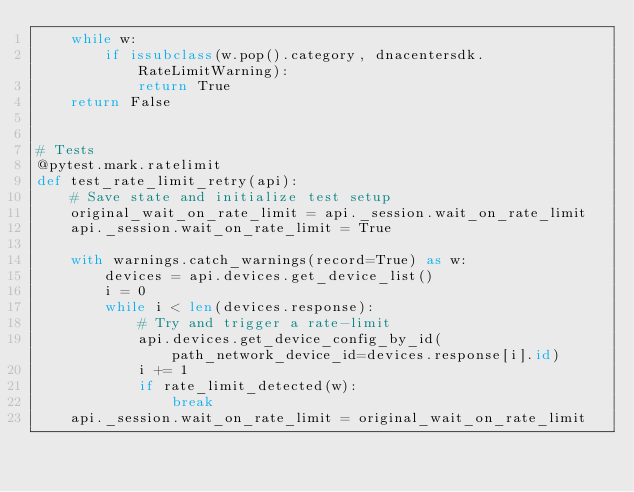<code> <loc_0><loc_0><loc_500><loc_500><_Python_>    while w:
        if issubclass(w.pop().category, dnacentersdk.RateLimitWarning):
            return True
    return False


# Tests
@pytest.mark.ratelimit
def test_rate_limit_retry(api):
    # Save state and initialize test setup
    original_wait_on_rate_limit = api._session.wait_on_rate_limit
    api._session.wait_on_rate_limit = True

    with warnings.catch_warnings(record=True) as w:
        devices = api.devices.get_device_list()
        i = 0
        while i < len(devices.response):
            # Try and trigger a rate-limit
            api.devices.get_device_config_by_id(path_network_device_id=devices.response[i].id)
            i += 1
            if rate_limit_detected(w):
                break
    api._session.wait_on_rate_limit = original_wait_on_rate_limit
</code> 